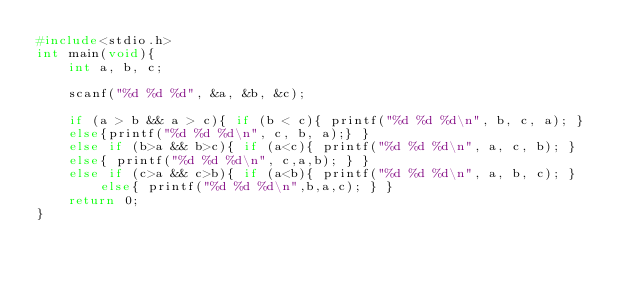<code> <loc_0><loc_0><loc_500><loc_500><_C_>#include<stdio.h>
int main(void){
	int a, b, c;

	scanf("%d %d %d", &a, &b, &c);

	if (a > b && a > c){ if (b < c){ printf("%d %d %d\n", b, c, a); }
	else{printf("%d %d %d\n", c, b, a);} }
	else if (b>a && b>c){ if (a<c){ printf("%d %d %d\n", a, c, b); } 
	else{ printf("%d %d %d\n", c,a,b); } }
	else if (c>a && c>b){ if (a<b){ printf("%d %d %d\n", a, b, c); } 
        else{ printf("%d %d %d\n",b,a,c); } }
	return 0;
}</code> 